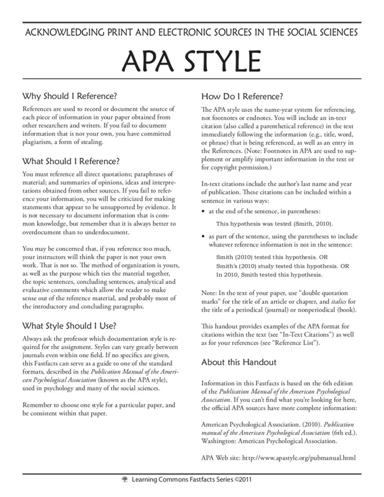How does APA style differ from other referencing styles? APA style primarily uses an author-date citation system, unlike the footnote or endnote system used in styles like Chicago. In APA, each citation in the text pairs an author's last name with the work's year of publication, enclosed in parentheses, and detailed source information is provided in the References section. This style contrasts with others by emphasizing concise author and date information to connect sources cited with those listed in References. 